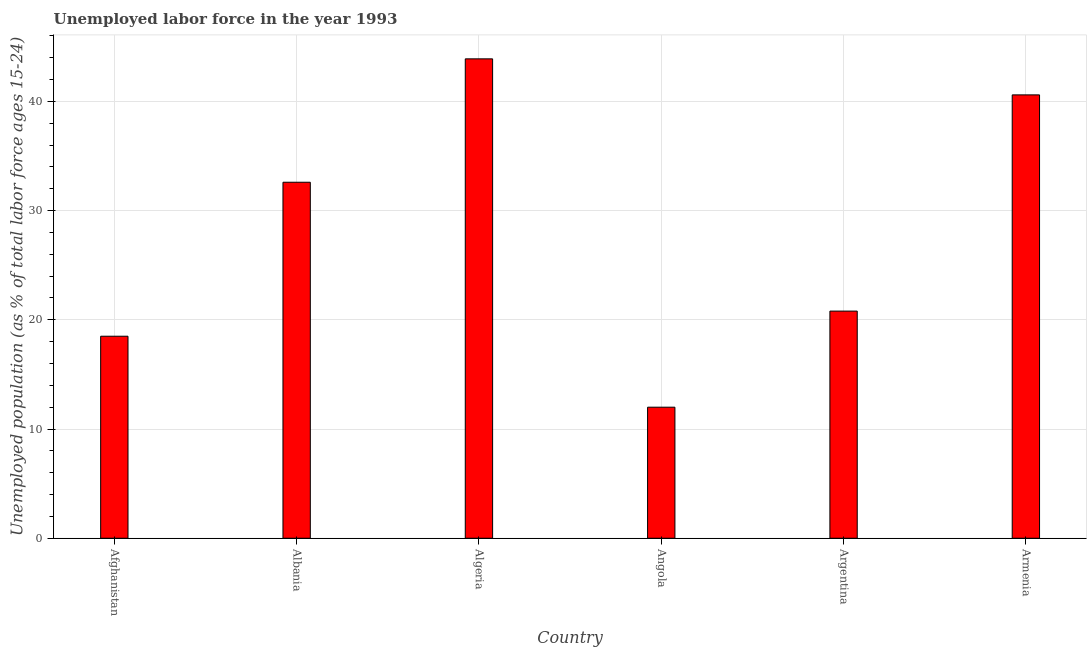Does the graph contain any zero values?
Your answer should be compact. No. Does the graph contain grids?
Make the answer very short. Yes. What is the title of the graph?
Offer a terse response. Unemployed labor force in the year 1993. What is the label or title of the X-axis?
Make the answer very short. Country. What is the label or title of the Y-axis?
Offer a very short reply. Unemployed population (as % of total labor force ages 15-24). Across all countries, what is the maximum total unemployed youth population?
Your answer should be compact. 43.9. Across all countries, what is the minimum total unemployed youth population?
Offer a very short reply. 12. In which country was the total unemployed youth population maximum?
Your response must be concise. Algeria. In which country was the total unemployed youth population minimum?
Offer a very short reply. Angola. What is the sum of the total unemployed youth population?
Provide a short and direct response. 168.4. What is the difference between the total unemployed youth population in Albania and Argentina?
Offer a very short reply. 11.8. What is the average total unemployed youth population per country?
Provide a succinct answer. 28.07. What is the median total unemployed youth population?
Your response must be concise. 26.7. What is the ratio of the total unemployed youth population in Albania to that in Argentina?
Make the answer very short. 1.57. What is the difference between the highest and the second highest total unemployed youth population?
Offer a very short reply. 3.3. What is the difference between the highest and the lowest total unemployed youth population?
Your response must be concise. 31.9. How many countries are there in the graph?
Provide a short and direct response. 6. What is the difference between two consecutive major ticks on the Y-axis?
Offer a terse response. 10. Are the values on the major ticks of Y-axis written in scientific E-notation?
Make the answer very short. No. What is the Unemployed population (as % of total labor force ages 15-24) in Albania?
Make the answer very short. 32.6. What is the Unemployed population (as % of total labor force ages 15-24) of Algeria?
Give a very brief answer. 43.9. What is the Unemployed population (as % of total labor force ages 15-24) in Angola?
Make the answer very short. 12. What is the Unemployed population (as % of total labor force ages 15-24) in Argentina?
Your answer should be compact. 20.8. What is the Unemployed population (as % of total labor force ages 15-24) of Armenia?
Your answer should be very brief. 40.6. What is the difference between the Unemployed population (as % of total labor force ages 15-24) in Afghanistan and Albania?
Your answer should be compact. -14.1. What is the difference between the Unemployed population (as % of total labor force ages 15-24) in Afghanistan and Algeria?
Your answer should be very brief. -25.4. What is the difference between the Unemployed population (as % of total labor force ages 15-24) in Afghanistan and Angola?
Offer a terse response. 6.5. What is the difference between the Unemployed population (as % of total labor force ages 15-24) in Afghanistan and Armenia?
Your answer should be very brief. -22.1. What is the difference between the Unemployed population (as % of total labor force ages 15-24) in Albania and Angola?
Keep it short and to the point. 20.6. What is the difference between the Unemployed population (as % of total labor force ages 15-24) in Albania and Armenia?
Give a very brief answer. -8. What is the difference between the Unemployed population (as % of total labor force ages 15-24) in Algeria and Angola?
Give a very brief answer. 31.9. What is the difference between the Unemployed population (as % of total labor force ages 15-24) in Algeria and Argentina?
Your response must be concise. 23.1. What is the difference between the Unemployed population (as % of total labor force ages 15-24) in Algeria and Armenia?
Provide a short and direct response. 3.3. What is the difference between the Unemployed population (as % of total labor force ages 15-24) in Angola and Argentina?
Provide a succinct answer. -8.8. What is the difference between the Unemployed population (as % of total labor force ages 15-24) in Angola and Armenia?
Your answer should be compact. -28.6. What is the difference between the Unemployed population (as % of total labor force ages 15-24) in Argentina and Armenia?
Your answer should be compact. -19.8. What is the ratio of the Unemployed population (as % of total labor force ages 15-24) in Afghanistan to that in Albania?
Keep it short and to the point. 0.57. What is the ratio of the Unemployed population (as % of total labor force ages 15-24) in Afghanistan to that in Algeria?
Your answer should be very brief. 0.42. What is the ratio of the Unemployed population (as % of total labor force ages 15-24) in Afghanistan to that in Angola?
Keep it short and to the point. 1.54. What is the ratio of the Unemployed population (as % of total labor force ages 15-24) in Afghanistan to that in Argentina?
Your answer should be compact. 0.89. What is the ratio of the Unemployed population (as % of total labor force ages 15-24) in Afghanistan to that in Armenia?
Provide a short and direct response. 0.46. What is the ratio of the Unemployed population (as % of total labor force ages 15-24) in Albania to that in Algeria?
Give a very brief answer. 0.74. What is the ratio of the Unemployed population (as % of total labor force ages 15-24) in Albania to that in Angola?
Offer a very short reply. 2.72. What is the ratio of the Unemployed population (as % of total labor force ages 15-24) in Albania to that in Argentina?
Your answer should be compact. 1.57. What is the ratio of the Unemployed population (as % of total labor force ages 15-24) in Albania to that in Armenia?
Your answer should be compact. 0.8. What is the ratio of the Unemployed population (as % of total labor force ages 15-24) in Algeria to that in Angola?
Make the answer very short. 3.66. What is the ratio of the Unemployed population (as % of total labor force ages 15-24) in Algeria to that in Argentina?
Offer a terse response. 2.11. What is the ratio of the Unemployed population (as % of total labor force ages 15-24) in Algeria to that in Armenia?
Make the answer very short. 1.08. What is the ratio of the Unemployed population (as % of total labor force ages 15-24) in Angola to that in Argentina?
Make the answer very short. 0.58. What is the ratio of the Unemployed population (as % of total labor force ages 15-24) in Angola to that in Armenia?
Make the answer very short. 0.3. What is the ratio of the Unemployed population (as % of total labor force ages 15-24) in Argentina to that in Armenia?
Your answer should be very brief. 0.51. 